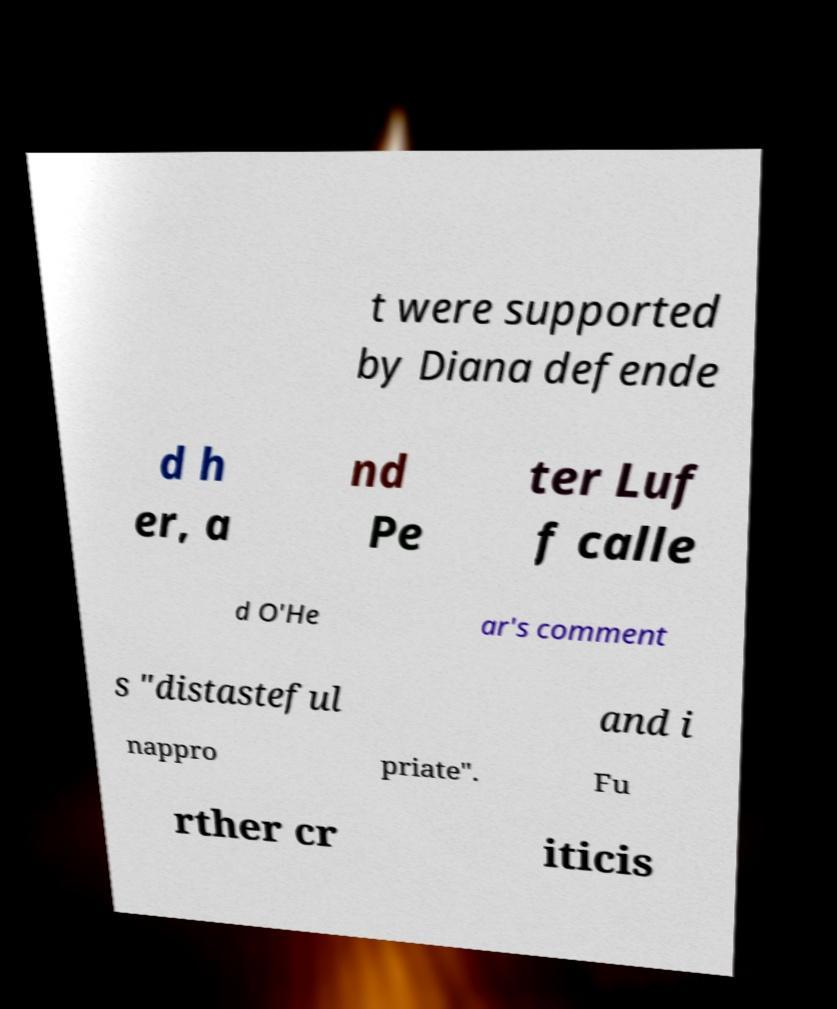Could you assist in decoding the text presented in this image and type it out clearly? t were supported by Diana defende d h er, a nd Pe ter Luf f calle d O'He ar's comment s "distasteful and i nappro priate". Fu rther cr iticis 